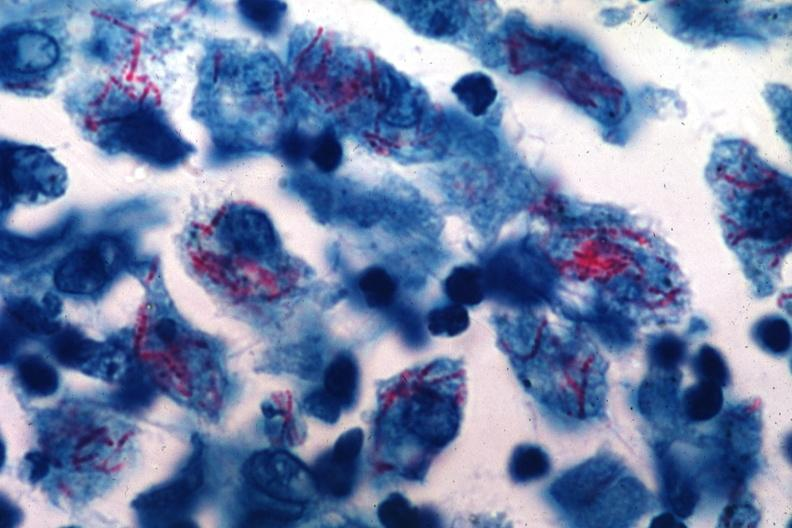what does this image show?
Answer the question using a single word or phrase. That acid fast stain many intracellular bacterial probably was an early case of mycobacterium intracellulare infection too many organisms for old time tb 